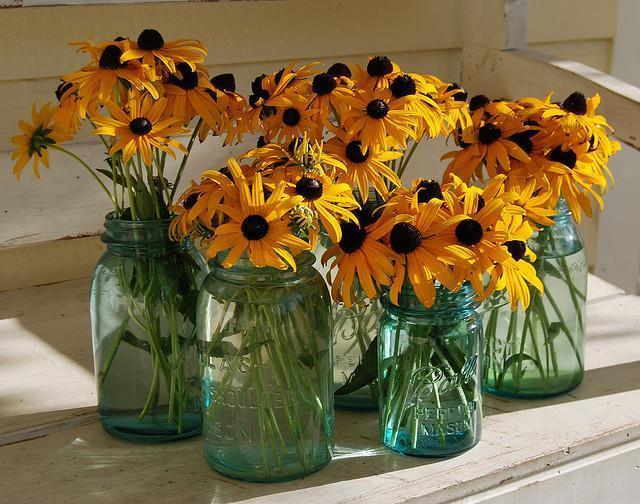How many jars are there?
Give a very brief answer. 5. How many vases are on the table?
Give a very brief answer. 5. How many vases in the picture?
Give a very brief answer. 5. How many vases are there?
Give a very brief answer. 5. 